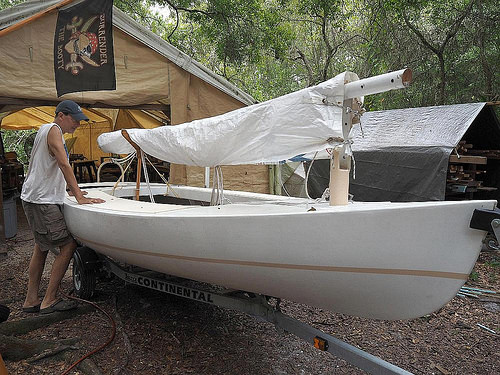<image>
Is there a man in front of the boat? No. The man is not in front of the boat. The spatial positioning shows a different relationship between these objects. 